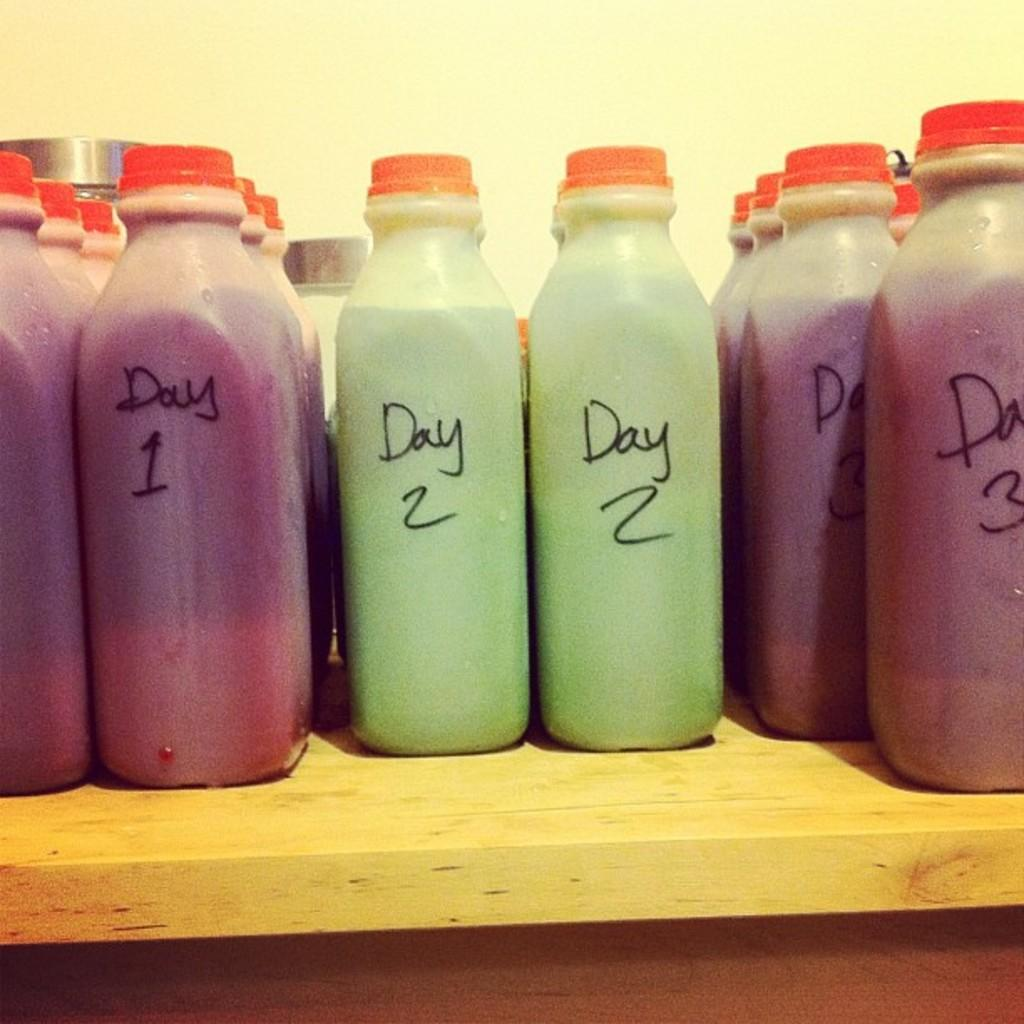<image>
Offer a succinct explanation of the picture presented. Many white plastic bottles with red lids are lined up and organized by Day 1, Day 2 and Day 3 on a wooden shelf. 